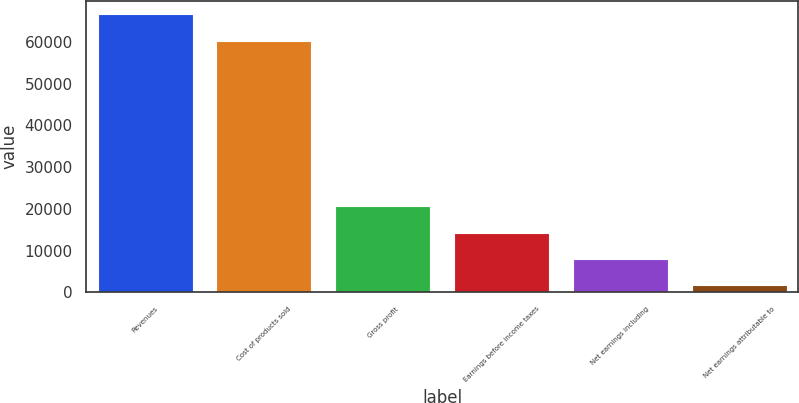<chart> <loc_0><loc_0><loc_500><loc_500><bar_chart><fcel>Revenues<fcel>Cost of products sold<fcel>Gross profit<fcel>Earnings before income taxes<fcel>Net earnings including<fcel>Net earnings attributable to<nl><fcel>66588<fcel>60319<fcel>20619<fcel>14350<fcel>8081<fcel>1812<nl></chart> 